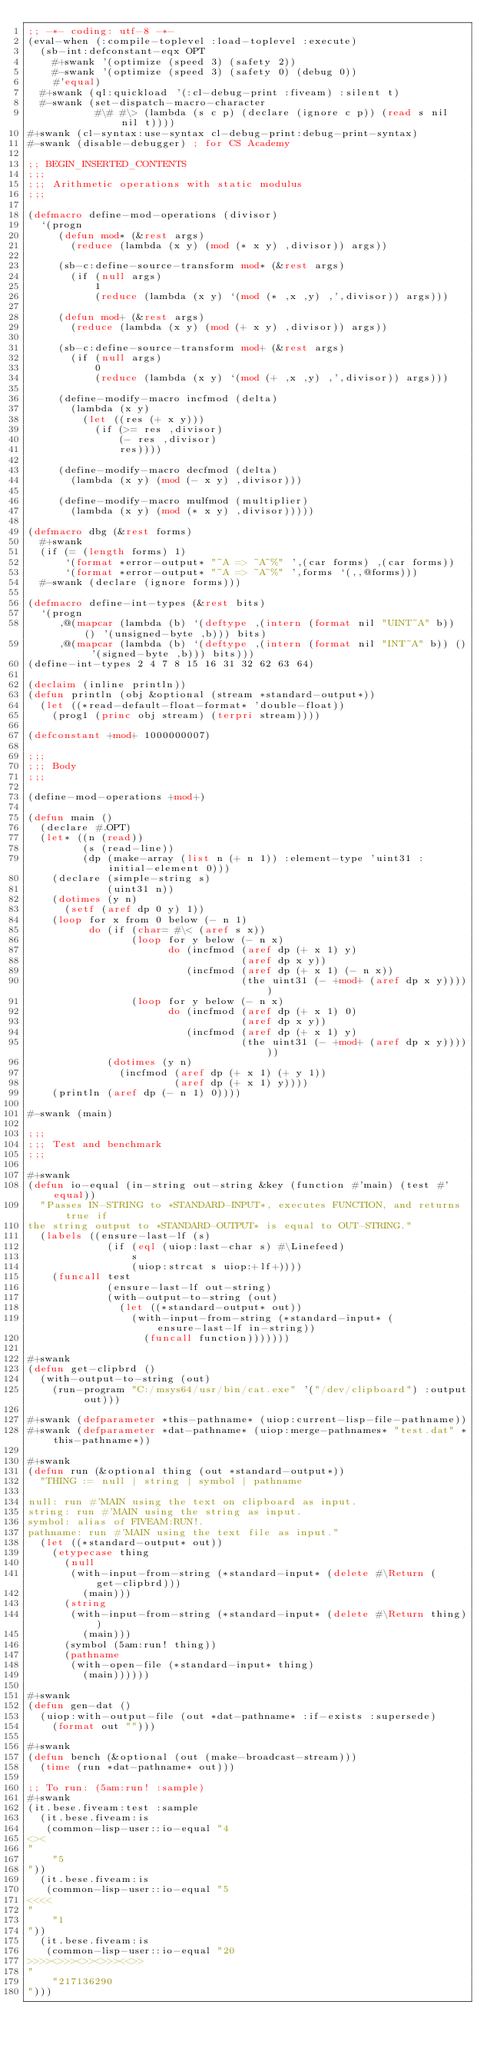<code> <loc_0><loc_0><loc_500><loc_500><_Lisp_>;; -*- coding: utf-8 -*-
(eval-when (:compile-toplevel :load-toplevel :execute)
  (sb-int:defconstant-eqx OPT
    #+swank '(optimize (speed 3) (safety 2))
    #-swank '(optimize (speed 3) (safety 0) (debug 0))
    #'equal)
  #+swank (ql:quickload '(:cl-debug-print :fiveam) :silent t)
  #-swank (set-dispatch-macro-character
           #\# #\> (lambda (s c p) (declare (ignore c p)) (read s nil nil t))))
#+swank (cl-syntax:use-syntax cl-debug-print:debug-print-syntax)
#-swank (disable-debugger) ; for CS Academy

;; BEGIN_INSERTED_CONTENTS
;;;
;;; Arithmetic operations with static modulus
;;;

(defmacro define-mod-operations (divisor)
  `(progn
     (defun mod* (&rest args)
       (reduce (lambda (x y) (mod (* x y) ,divisor)) args))

     (sb-c:define-source-transform mod* (&rest args)
       (if (null args)
           1
           (reduce (lambda (x y) `(mod (* ,x ,y) ,',divisor)) args)))

     (defun mod+ (&rest args)
       (reduce (lambda (x y) (mod (+ x y) ,divisor)) args))

     (sb-c:define-source-transform mod+ (&rest args)
       (if (null args)
           0
           (reduce (lambda (x y) `(mod (+ ,x ,y) ,',divisor)) args)))

     (define-modify-macro incfmod (delta)
       (lambda (x y)
         (let ((res (+ x y)))
           (if (>= res ,divisor)
               (- res ,divisor)
               res))))

     (define-modify-macro decfmod (delta)
       (lambda (x y) (mod (- x y) ,divisor)))

     (define-modify-macro mulfmod (multiplier)
       (lambda (x y) (mod (* x y) ,divisor)))))

(defmacro dbg (&rest forms)
  #+swank
  (if (= (length forms) 1)
      `(format *error-output* "~A => ~A~%" ',(car forms) ,(car forms))
      `(format *error-output* "~A => ~A~%" ',forms `(,,@forms)))
  #-swank (declare (ignore forms)))

(defmacro define-int-types (&rest bits)
  `(progn
     ,@(mapcar (lambda (b) `(deftype ,(intern (format nil "UINT~A" b)) () '(unsigned-byte ,b))) bits)
     ,@(mapcar (lambda (b) `(deftype ,(intern (format nil "INT~A" b)) () '(signed-byte ,b))) bits)))
(define-int-types 2 4 7 8 15 16 31 32 62 63 64)

(declaim (inline println))
(defun println (obj &optional (stream *standard-output*))
  (let ((*read-default-float-format* 'double-float))
    (prog1 (princ obj stream) (terpri stream))))

(defconstant +mod+ 1000000007)

;;;
;;; Body
;;;

(define-mod-operations +mod+)

(defun main ()
  (declare #.OPT)
  (let* ((n (read))
         (s (read-line))
         (dp (make-array (list n (+ n 1)) :element-type 'uint31 :initial-element 0)))
    (declare (simple-string s)
             (uint31 n))
    (dotimes (y n)
      (setf (aref dp 0 y) 1))
    (loop for x from 0 below (- n 1)
          do (if (char= #\< (aref s x))
                 (loop for y below (- n x)
                       do (incfmod (aref dp (+ x 1) y)
                                   (aref dp x y))
                          (incfmod (aref dp (+ x 1) (- n x))
                                   (the uint31 (- +mod+ (aref dp x y)))))
                 (loop for y below (- n x)
                       do (incfmod (aref dp (+ x 1) 0)
                                   (aref dp x y))
                          (incfmod (aref dp (+ x 1) y)
                                   (the uint31 (- +mod+ (aref dp x y))))))
             (dotimes (y n)
               (incfmod (aref dp (+ x 1) (+ y 1))
                        (aref dp (+ x 1) y))))
    (println (aref dp (- n 1) 0))))

#-swank (main)

;;;
;;; Test and benchmark
;;;

#+swank
(defun io-equal (in-string out-string &key (function #'main) (test #'equal))
  "Passes IN-STRING to *STANDARD-INPUT*, executes FUNCTION, and returns true if
the string output to *STANDARD-OUTPUT* is equal to OUT-STRING."
  (labels ((ensure-last-lf (s)
             (if (eql (uiop:last-char s) #\Linefeed)
                 s
                 (uiop:strcat s uiop:+lf+))))
    (funcall test
             (ensure-last-lf out-string)
             (with-output-to-string (out)
               (let ((*standard-output* out))
                 (with-input-from-string (*standard-input* (ensure-last-lf in-string))
                   (funcall function)))))))

#+swank
(defun get-clipbrd ()
  (with-output-to-string (out)
    (run-program "C:/msys64/usr/bin/cat.exe" '("/dev/clipboard") :output out)))

#+swank (defparameter *this-pathname* (uiop:current-lisp-file-pathname))
#+swank (defparameter *dat-pathname* (uiop:merge-pathnames* "test.dat" *this-pathname*))

#+swank
(defun run (&optional thing (out *standard-output*))
  "THING := null | string | symbol | pathname

null: run #'MAIN using the text on clipboard as input.
string: run #'MAIN using the string as input.
symbol: alias of FIVEAM:RUN!.
pathname: run #'MAIN using the text file as input."
  (let ((*standard-output* out))
    (etypecase thing
      (null
       (with-input-from-string (*standard-input* (delete #\Return (get-clipbrd)))
         (main)))
      (string
       (with-input-from-string (*standard-input* (delete #\Return thing))
         (main)))
      (symbol (5am:run! thing))
      (pathname
       (with-open-file (*standard-input* thing)
         (main))))))

#+swank
(defun gen-dat ()
  (uiop:with-output-file (out *dat-pathname* :if-exists :supersede)
    (format out "")))

#+swank
(defun bench (&optional (out (make-broadcast-stream)))
  (time (run *dat-pathname* out)))

;; To run: (5am:run! :sample)
#+swank
(it.bese.fiveam:test :sample
  (it.bese.fiveam:is
   (common-lisp-user::io-equal "4
<><
"
    "5
"))
  (it.bese.fiveam:is
   (common-lisp-user::io-equal "5
<<<<
"
    "1
"))
  (it.bese.fiveam:is
   (common-lisp-user::io-equal "20
>>>><>>><>><>>><<>>
"
    "217136290
")))
</code> 